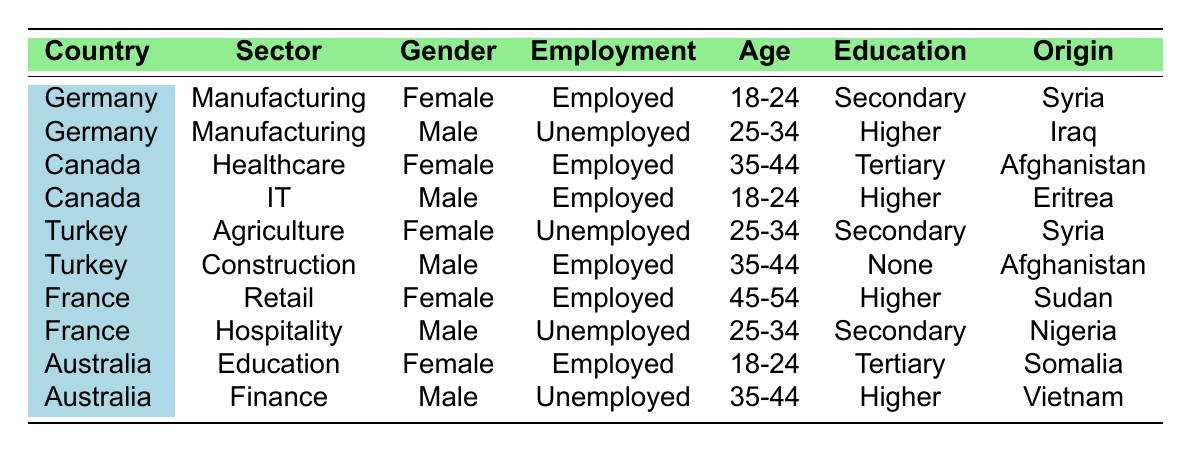What is the employment status of refugees from Syria in Germany? There are two entries for refugees from Syria in Germany. One is employed (female in manufacturing) and the other is unemployed (female in agriculture). Since we are looking for the employment status, we see that both statuses are represented.
Answer: Employed and Unemployed How many male refugees are employed in Canada? There are two male refugees in Canada, one in healthcare and one in IT. Both are employed, so we count them, which gives us a total of two employed male refugees.
Answer: 2 What is the age group of the unemployed male refugees in France? There is one unemployed male refugee in France who falls within the age group of 25-34 years, based on the entry in the table for hospitality sector.
Answer: 25-34 Are there any refugees from Afghanistan employed in Turkey? In Turkey, the only refugee from Afghanistan is a male in the construction sector who is employed. Hence, the statement is true.
Answer: Yes What percentage of the total refugee entries in the table are employed? There are 10 total entries in the table and 6 of them report being employed (employment statuses are visible). To find the percentage, (6/10)*100 equals 60%.
Answer: 60% How many refugees are unemployed in the age group 25-34? In the table, there are two entries for the age group 25-34: one for a male in France (hospitality) and one for a female in Turkey (agriculture). Thus, counting both gives us a total of two unemployed refugees in that age group.
Answer: 2 What is the highest level of education among employed female refugees? The employed female refugees in the table have education levels of secondary and tertiary. To find the highest level, we note that tertiary education is considered the highest compared to secondary education, thus leading us to the answer.
Answer: Tertiary education Count the total number of employed male refugees across all countries. From the entries in the table, we can identify that there are employed males in Canada (IT), Turkey (Construction), and Australia (Finance). Summing these gives us a total of 3 employed male refugees.
Answer: 3 Which country has the highest number of unemployed refugees listed in the table? By reviewing the entries, Germany has 1 unemployed (male sector: manufacturing), Turkey has 1 unemployed (female in agriculture), France has 1 unemployed (male in hospitality), and Australia has 1 unemployed (male in finance). There’s a tie, as all listed countries have 1 unemployed refugee each.
Answer: Tie among Germany, Turkey, France, and Australia What is the most common employment sector among employed refugees? Looking at the sectors where employed refugees are represented, we find (Manufacturing, Healthcare, IT, Retail, Education, and Construction). The sector with the most entries is the unifies. Each sector has at least one employed refugee; hence there is no clear most common.
Answer: No clear most common sector 